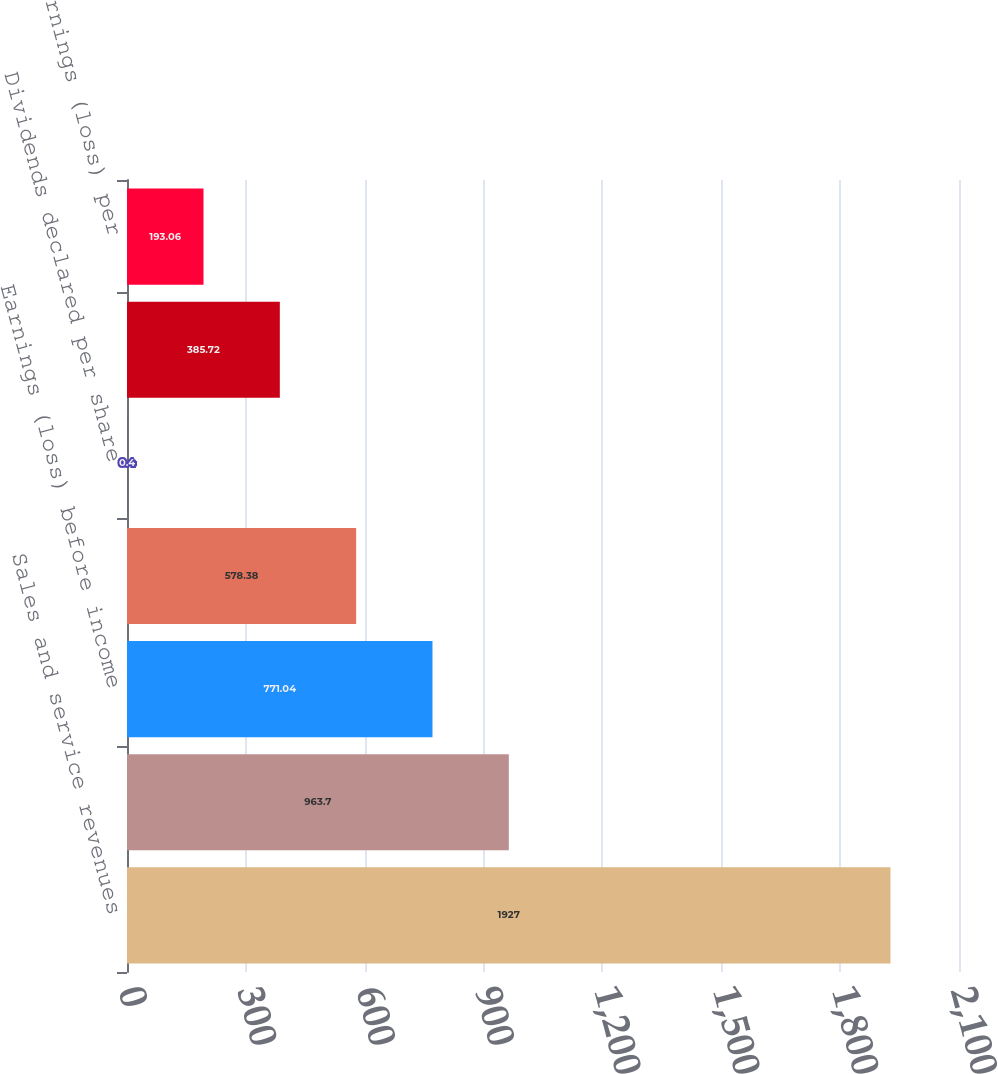<chart> <loc_0><loc_0><loc_500><loc_500><bar_chart><fcel>Sales and service revenues<fcel>Operating income (loss)<fcel>Earnings (loss) before income<fcel>Net earnings (loss)<fcel>Dividends declared per share<fcel>Basic earnings (loss) per<fcel>Diluted earnings (loss) per<nl><fcel>1927<fcel>963.7<fcel>771.04<fcel>578.38<fcel>0.4<fcel>385.72<fcel>193.06<nl></chart> 